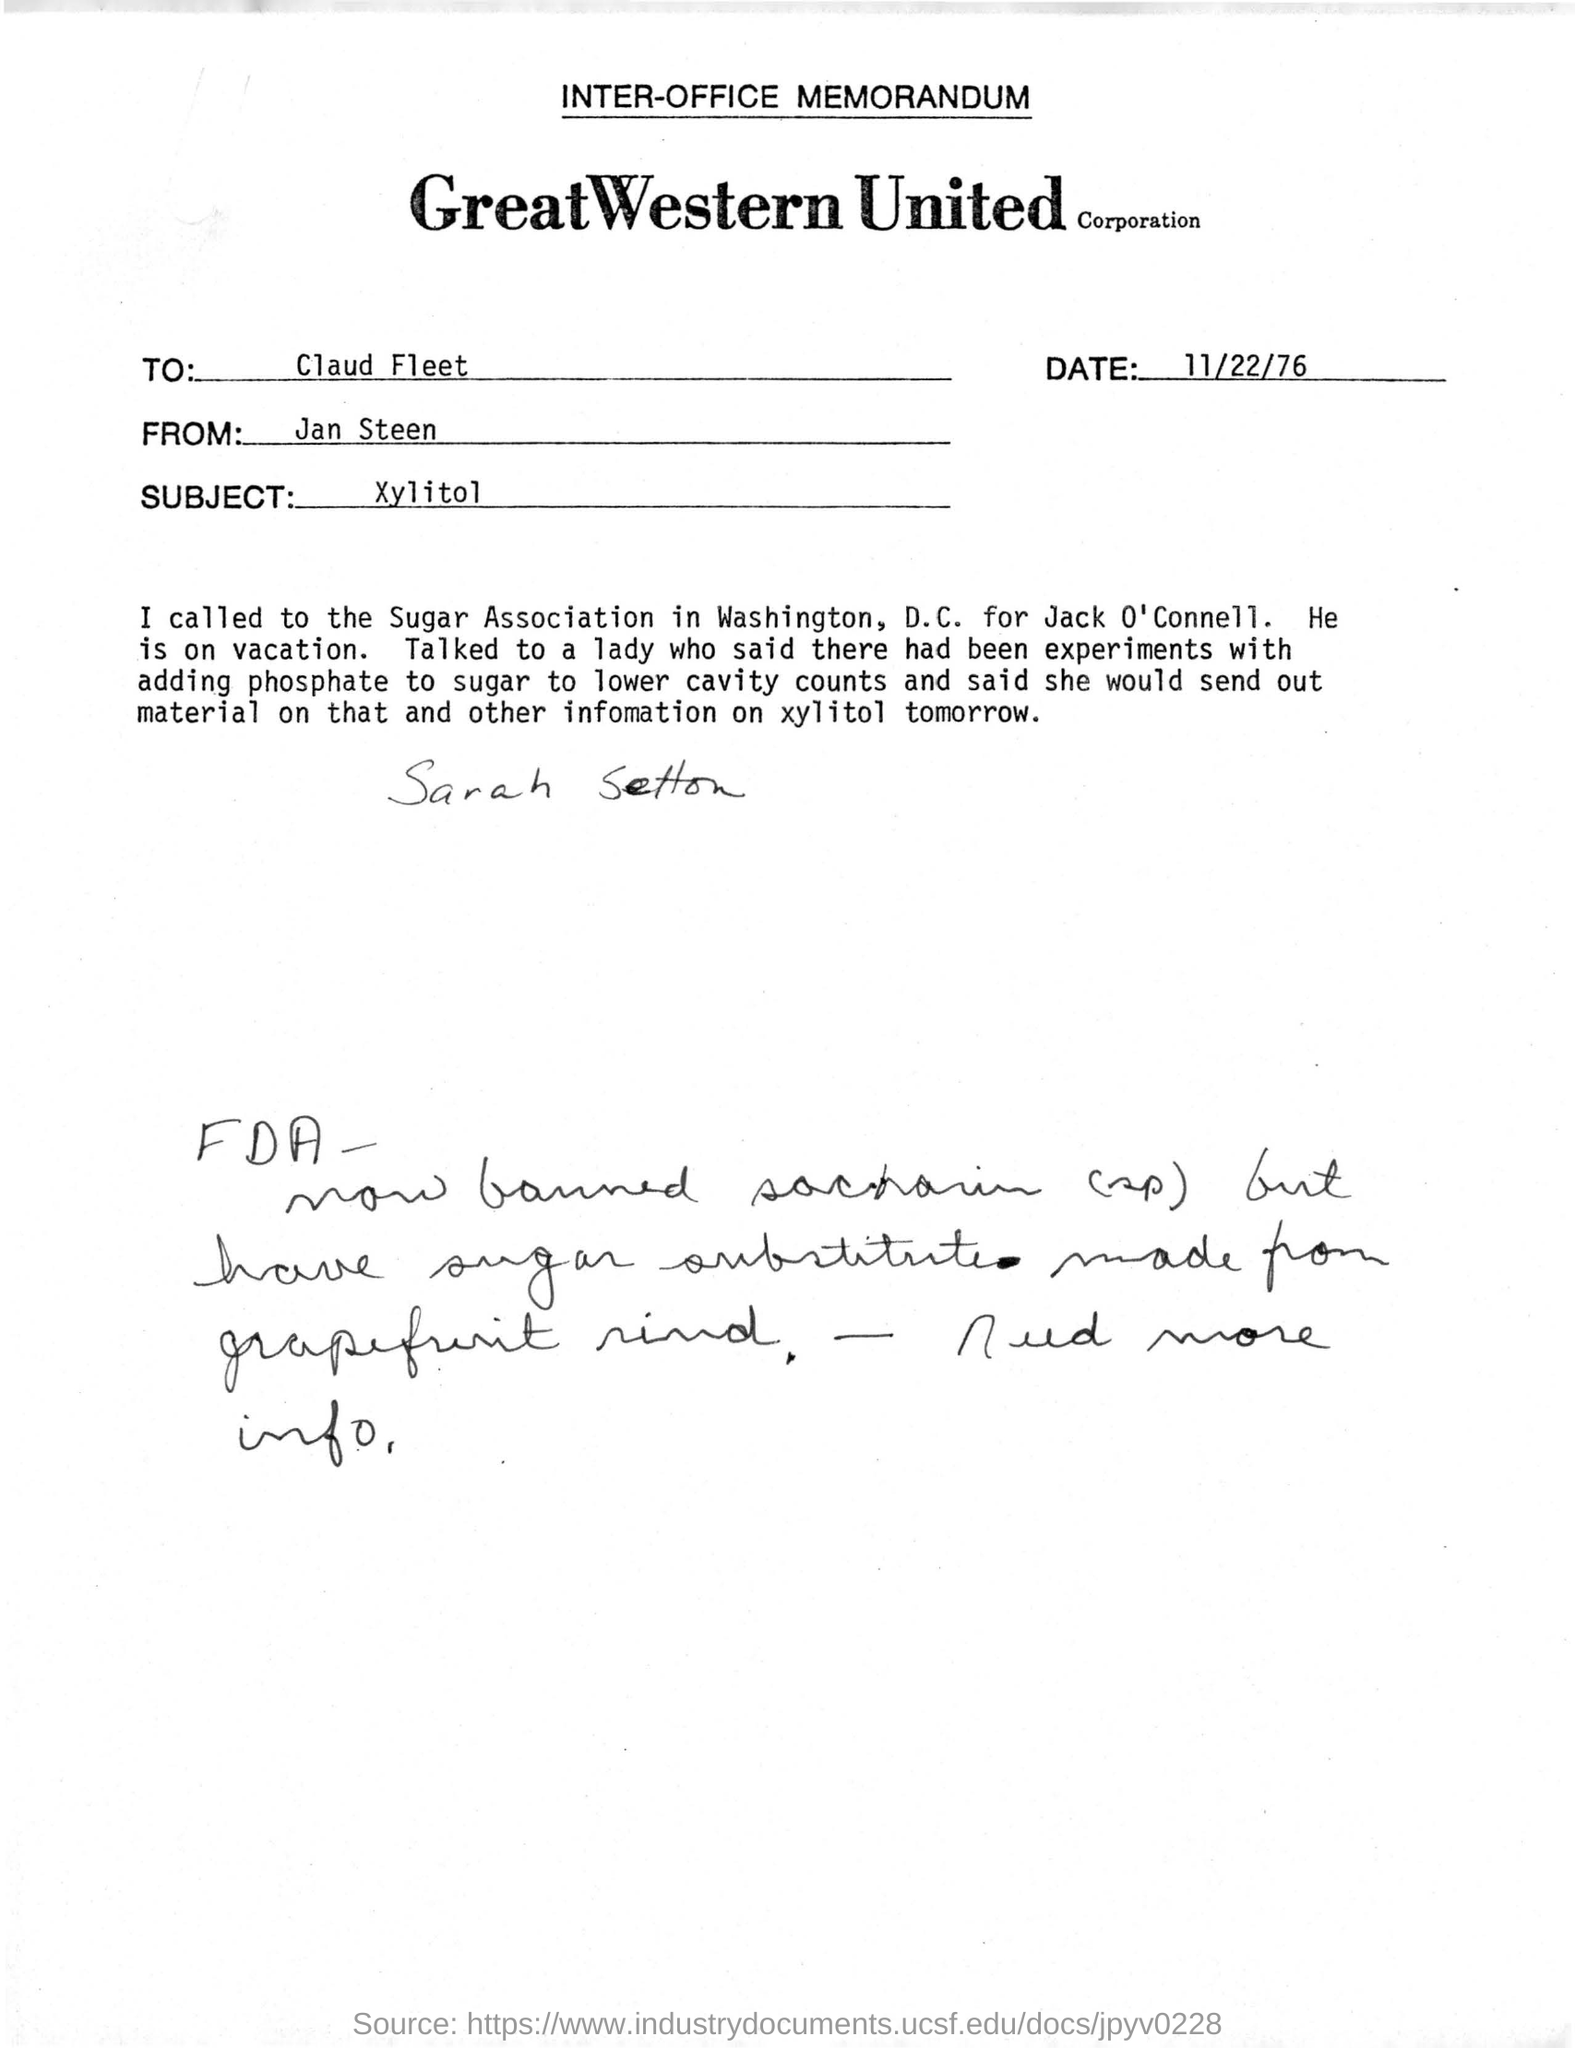What kind of memorandum is this ?
Offer a terse response. INTER-OFFICE MEMORANDUM. Which company's memorandum is given here?
Provide a succinct answer. GreatWestern United Corporation. Who is the sender of this memorandum?
Give a very brief answer. Jan Steen. Who is the receiver ?
Give a very brief answer. Claud Fleet. What is the subject of this memorandum?
Provide a short and direct response. Xylitol. When is the memorandum dated?
Offer a terse response. 11/22/76. What is the name written by hand below the content of the memo?
Ensure brevity in your answer.  Sarah Setton. 